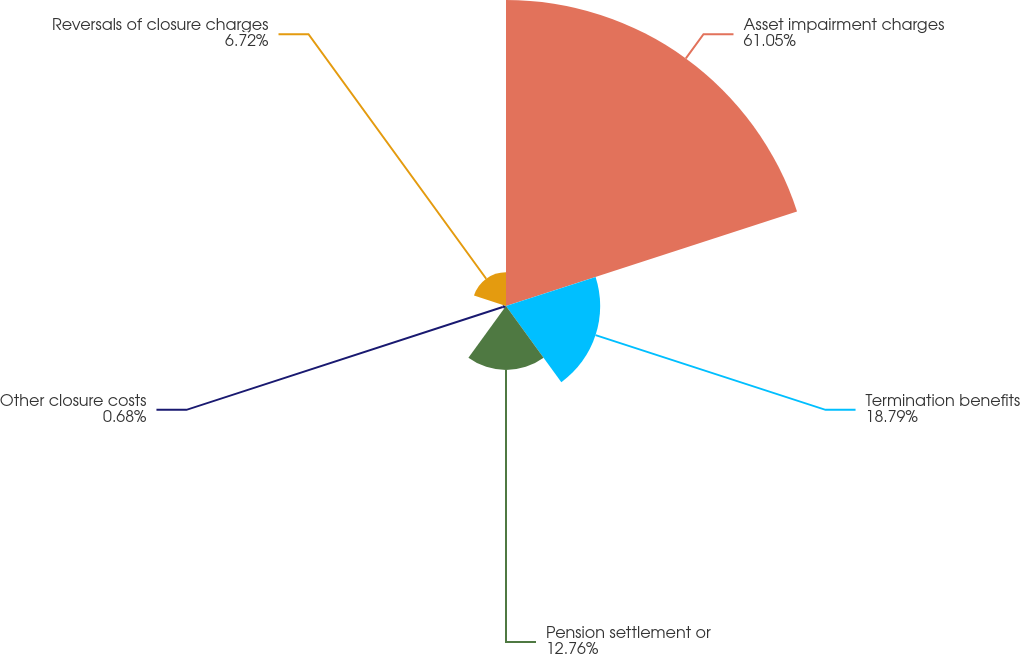Convert chart to OTSL. <chart><loc_0><loc_0><loc_500><loc_500><pie_chart><fcel>Asset impairment charges<fcel>Termination benefits<fcel>Pension settlement or<fcel>Other closure costs<fcel>Reversals of closure charges<nl><fcel>61.05%<fcel>18.79%<fcel>12.76%<fcel>0.68%<fcel>6.72%<nl></chart> 